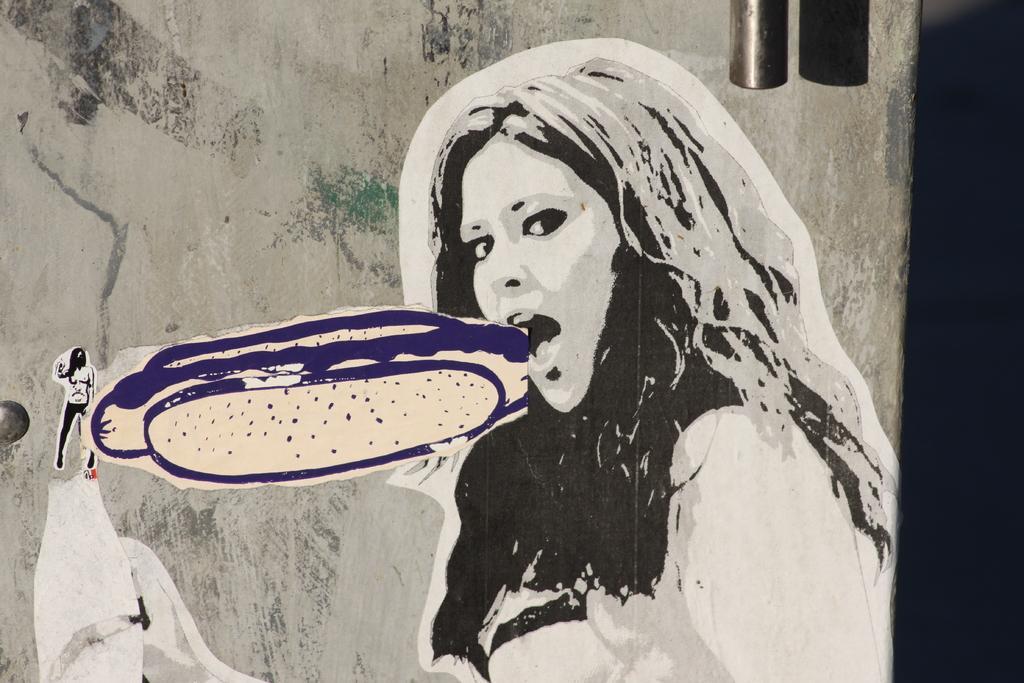How would you summarize this image in a sentence or two? In this image, we can see some art on the wall. We can also see an object at the top. 